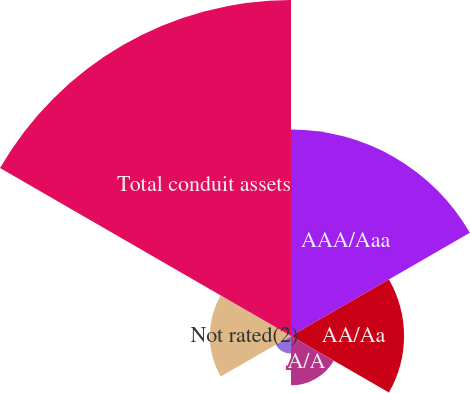Convert chart to OTSL. <chart><loc_0><loc_0><loc_500><loc_500><pie_chart><fcel>AAA/Aaa<fcel>AA/Aa<fcel>A/A<fcel>BBB/Baa<fcel>Not rated(2)<fcel>Total conduit assets<nl><fcel>25.7%<fcel>14.07%<fcel>6.14%<fcel>2.18%<fcel>10.1%<fcel>41.81%<nl></chart> 